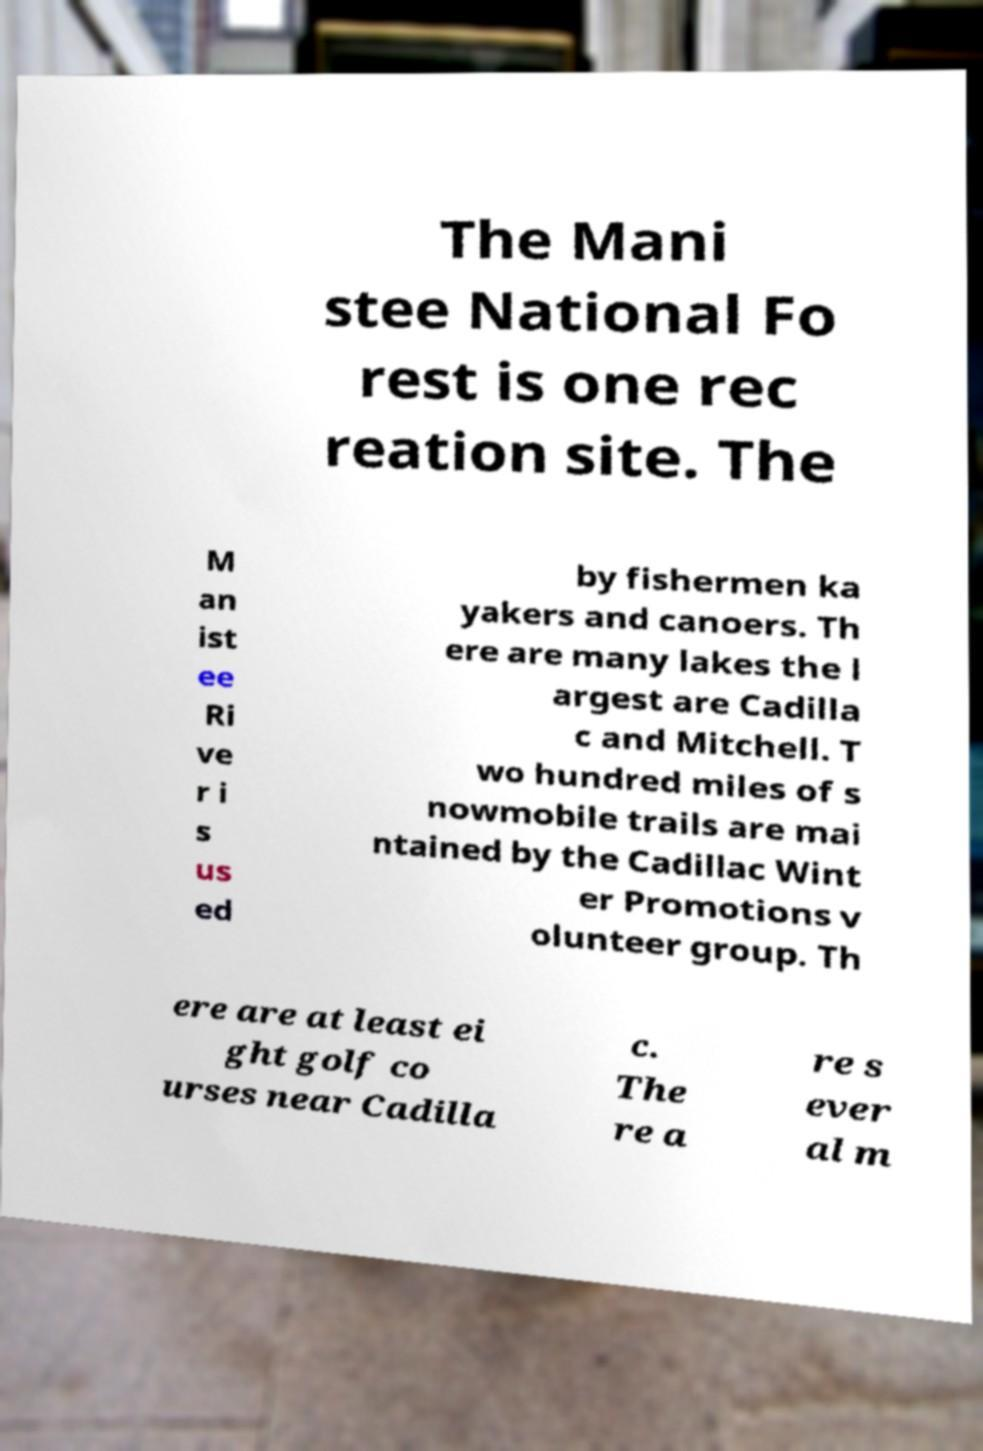Can you accurately transcribe the text from the provided image for me? The Mani stee National Fo rest is one rec reation site. The M an ist ee Ri ve r i s us ed by fishermen ka yakers and canoers. Th ere are many lakes the l argest are Cadilla c and Mitchell. T wo hundred miles of s nowmobile trails are mai ntained by the Cadillac Wint er Promotions v olunteer group. Th ere are at least ei ght golf co urses near Cadilla c. The re a re s ever al m 